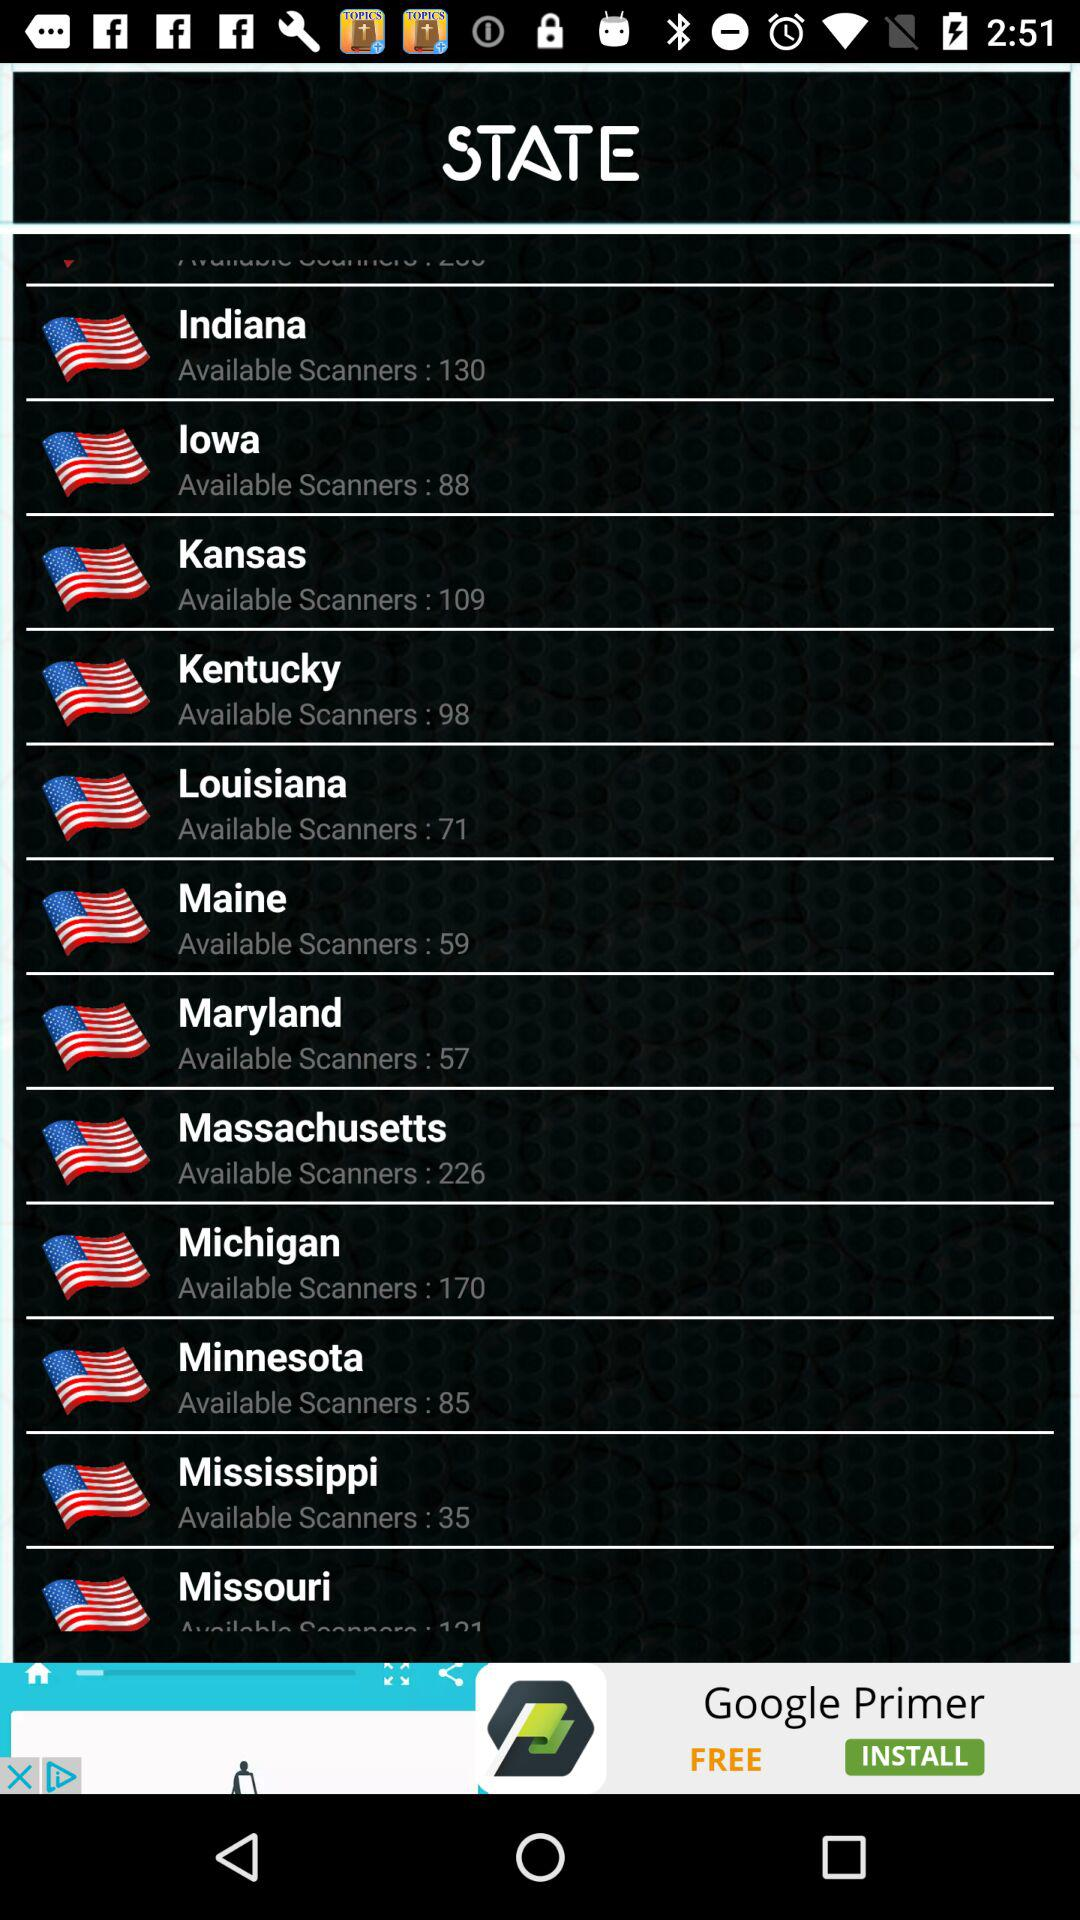In Kansas, how many scanners are there? There are 109 scanners in Kansas. 